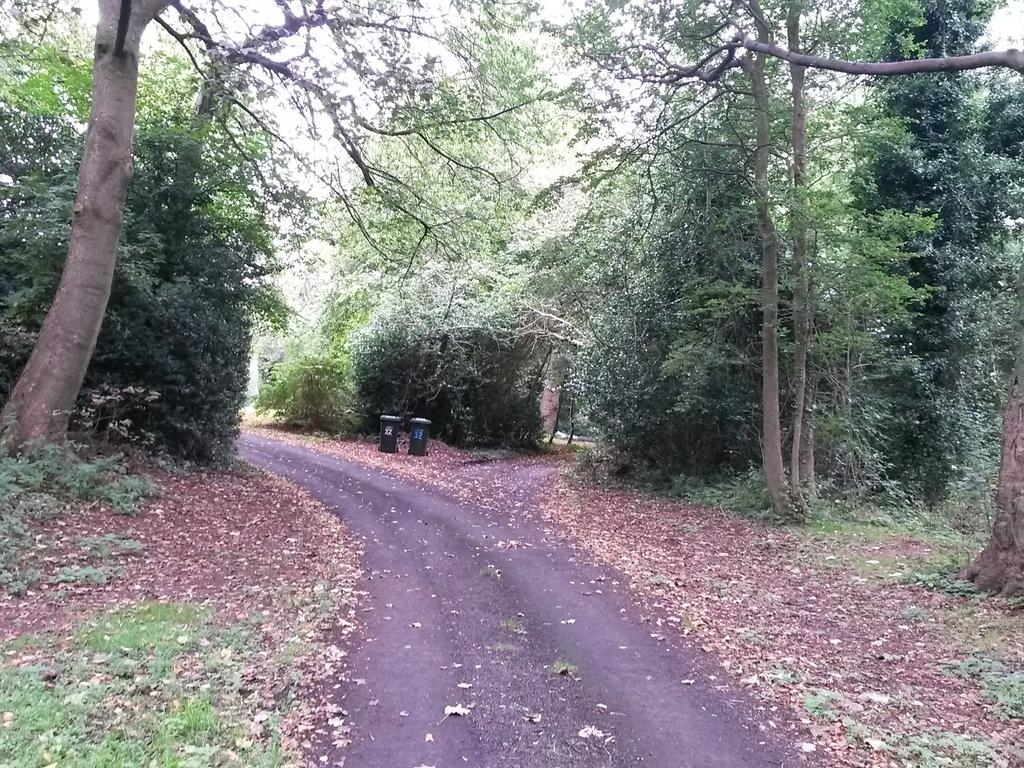What is the main feature in the center of the image? There is a path in the center of the image. What type of vegetation can be seen on the right side of the image? There are trees on the right side of the image. What type of vegetation can be seen on the left side of the image? There are trees on the left side of the image. What type of wine is being served at the table in the image? There is no table or wine present in the image; it features a path with trees on both sides. Can you provide a copy of the receipt for the appliance purchased in the image? There is no appliance or receipt present in the image; it only shows a path with trees on both sides. 